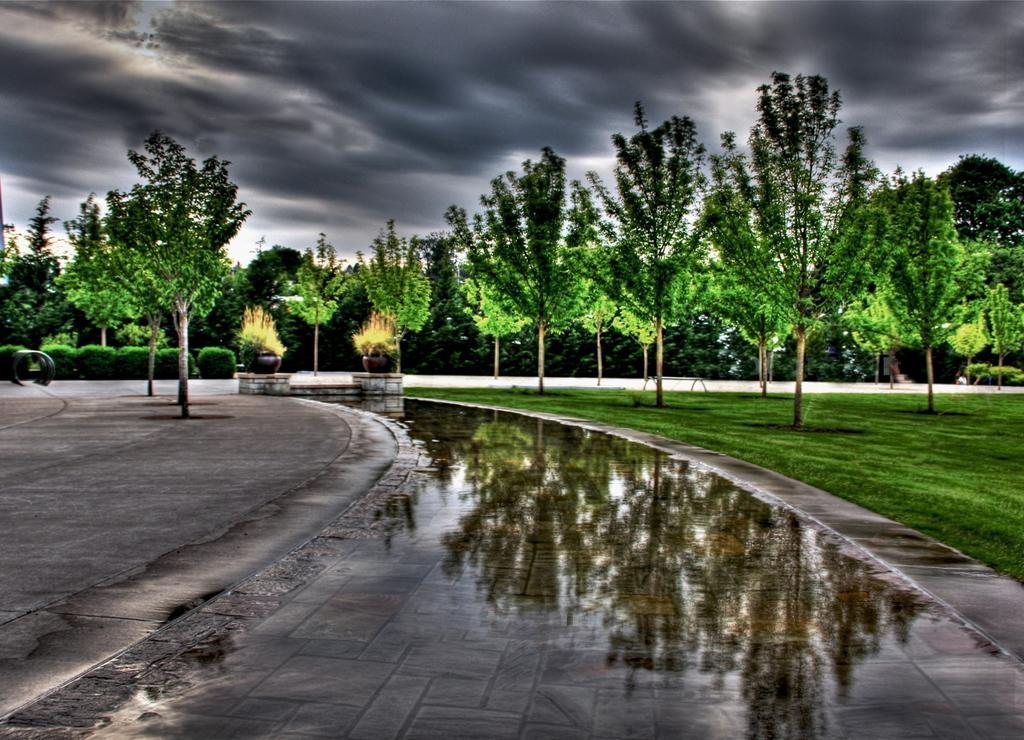What type of vegetation can be seen in the image? There are trees and plants in the image. What is present at the bottom of the image? There is water at the bottom of the image. What can be seen in the background of the image? The sky is visible in the background of the image. Where is the throne located in the image? There is no throne present in the image. How does the truck affect the plants in the image? There is no truck present in the image, so it cannot affect the plants. 